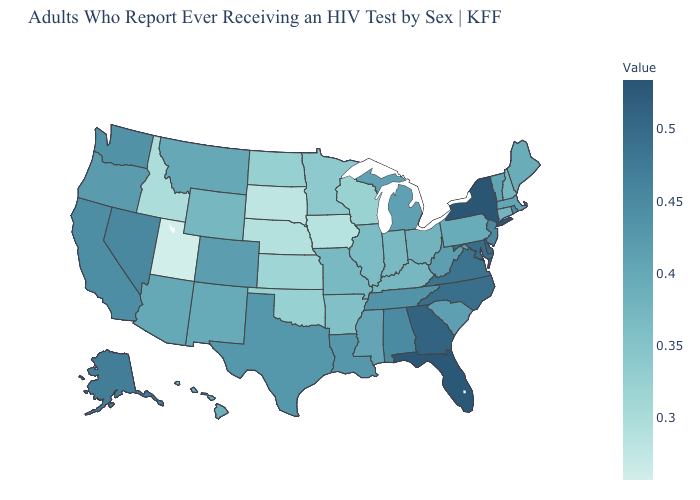Among the states that border Michigan , does Ohio have the lowest value?
Short answer required. No. Does Pennsylvania have the lowest value in the Northeast?
Write a very short answer. No. Does New York have the highest value in the USA?
Keep it brief. Yes. Among the states that border Texas , which have the highest value?
Concise answer only. Louisiana. Does Iowa have the lowest value in the USA?
Quick response, please. No. Which states hav the highest value in the Northeast?
Write a very short answer. New York. 